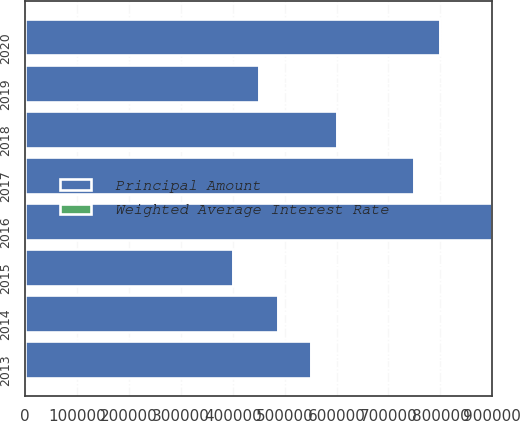Convert chart. <chart><loc_0><loc_0><loc_500><loc_500><stacked_bar_chart><ecel><fcel>2013<fcel>2014<fcel>2015<fcel>2016<fcel>2017<fcel>2018<fcel>2019<fcel>2020<nl><fcel>Principal Amount<fcel>550000<fcel>487000<fcel>400000<fcel>900000<fcel>750000<fcel>600000<fcel>450000<fcel>800000<nl><fcel>Weighted Average Interest Rate<fcel>5.8<fcel>3.15<fcel>6.64<fcel>5.07<fcel>6.04<fcel>6.83<fcel>3.96<fcel>2.79<nl></chart> 